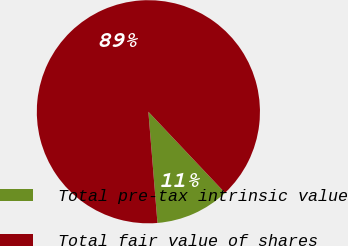Convert chart to OTSL. <chart><loc_0><loc_0><loc_500><loc_500><pie_chart><fcel>Total pre-tax intrinsic value<fcel>Total fair value of shares<nl><fcel>10.75%<fcel>89.25%<nl></chart> 